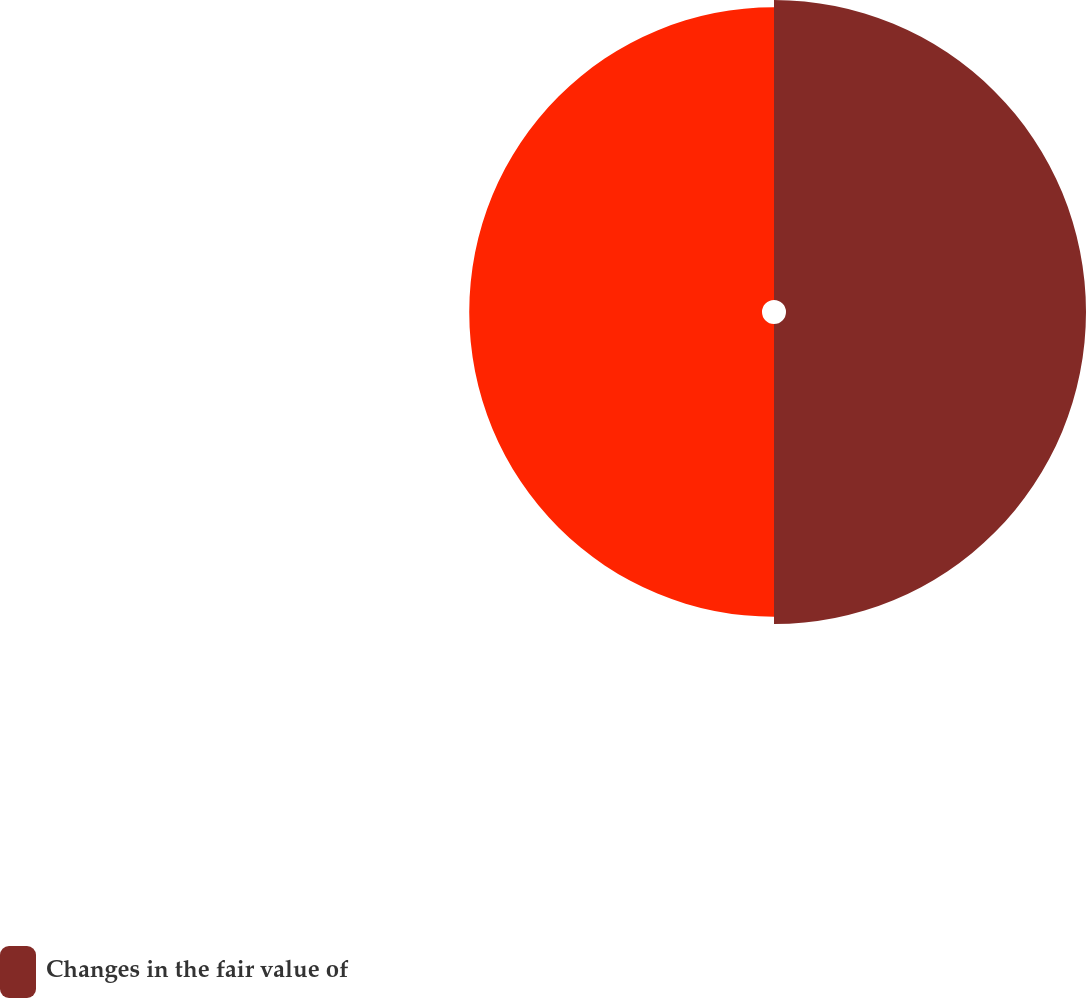Convert chart to OTSL. <chart><loc_0><loc_0><loc_500><loc_500><pie_chart><fcel>Changes in the fair value of<fcel>Unnamed: 1<nl><fcel>50.61%<fcel>49.39%<nl></chart> 